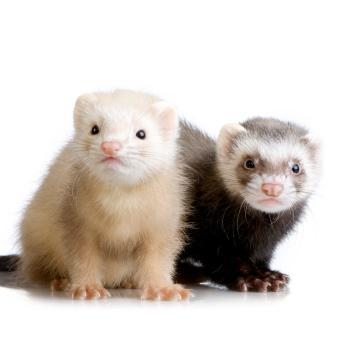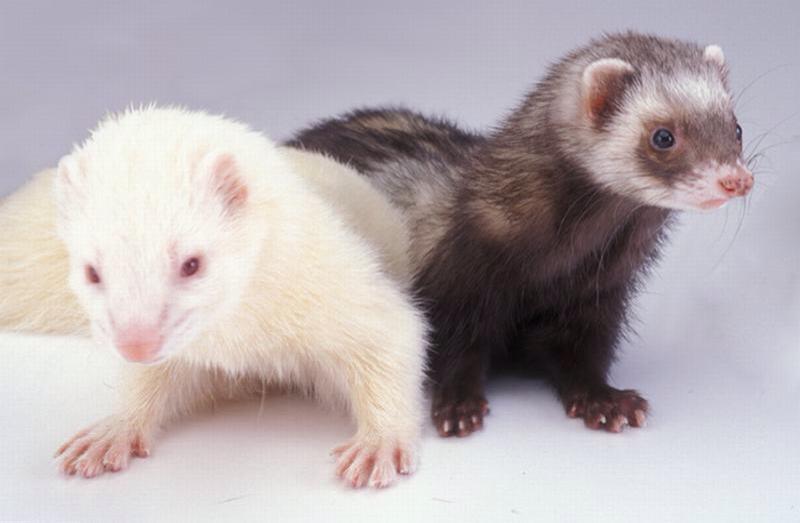The first image is the image on the left, the second image is the image on the right. Examine the images to the left and right. Is the description "There are two animals in the image on the right." accurate? Answer yes or no. Yes. 